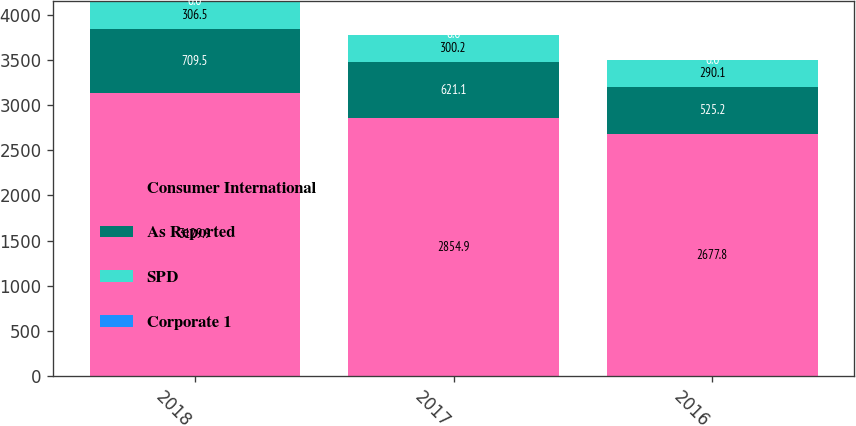Convert chart. <chart><loc_0><loc_0><loc_500><loc_500><stacked_bar_chart><ecel><fcel>2018<fcel>2017<fcel>2016<nl><fcel>Consumer International<fcel>3129.9<fcel>2854.9<fcel>2677.8<nl><fcel>As Reported<fcel>709.5<fcel>621.1<fcel>525.2<nl><fcel>SPD<fcel>306.5<fcel>300.2<fcel>290.1<nl><fcel>Corporate 1<fcel>0<fcel>0<fcel>0<nl></chart> 